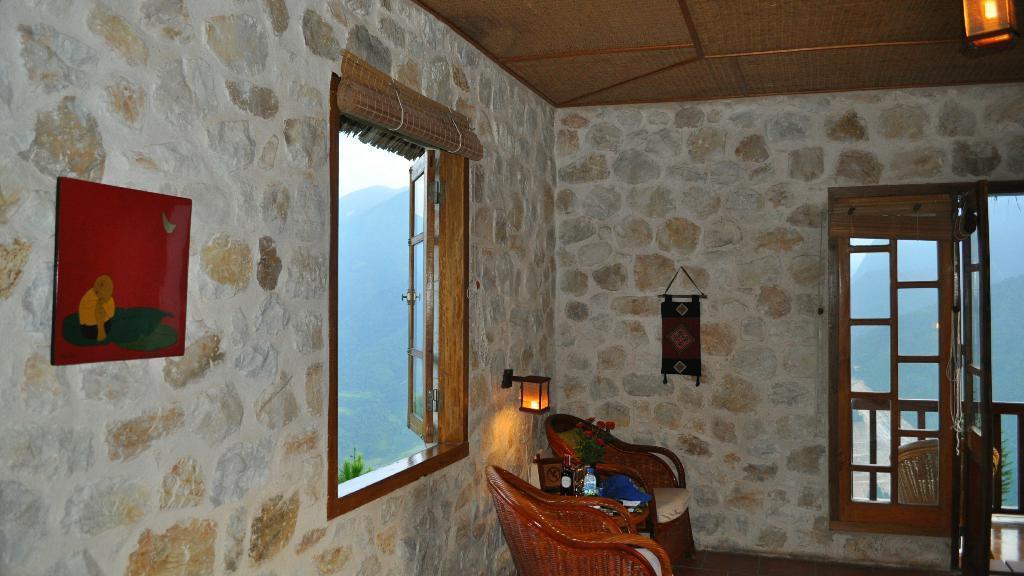Could you give a brief overview of what you see in this image? In this picture there are windows on the right and left side of the image and there are chairs at the bottom side of the image. 